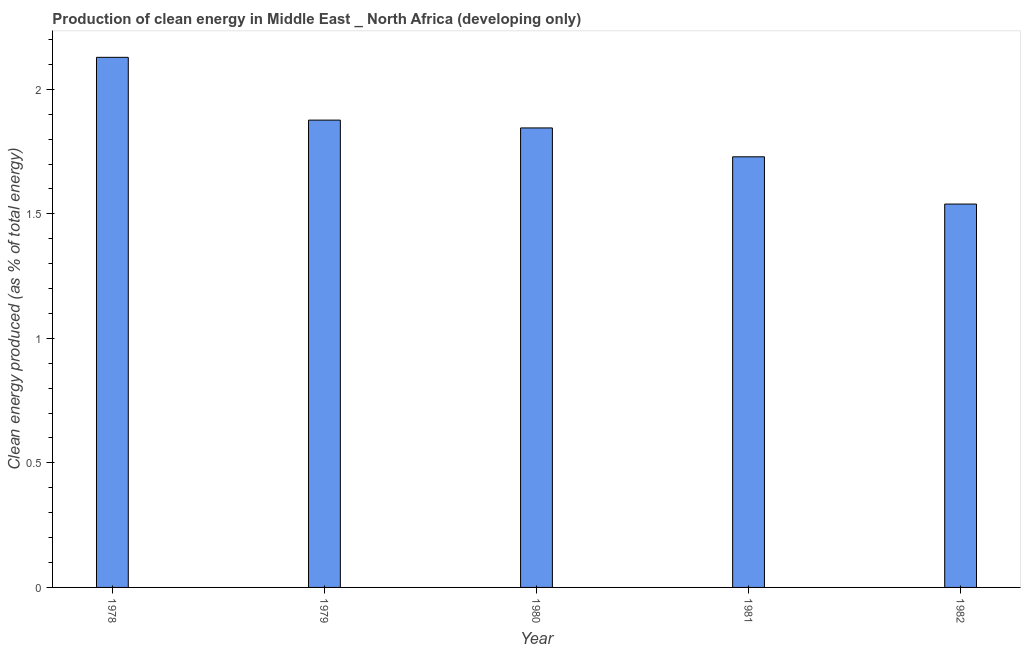Does the graph contain grids?
Ensure brevity in your answer.  No. What is the title of the graph?
Your answer should be very brief. Production of clean energy in Middle East _ North Africa (developing only). What is the label or title of the Y-axis?
Give a very brief answer. Clean energy produced (as % of total energy). What is the production of clean energy in 1978?
Keep it short and to the point. 2.13. Across all years, what is the maximum production of clean energy?
Offer a very short reply. 2.13. Across all years, what is the minimum production of clean energy?
Offer a very short reply. 1.54. In which year was the production of clean energy maximum?
Your response must be concise. 1978. In which year was the production of clean energy minimum?
Your response must be concise. 1982. What is the sum of the production of clean energy?
Provide a short and direct response. 9.12. What is the difference between the production of clean energy in 1978 and 1982?
Your answer should be very brief. 0.59. What is the average production of clean energy per year?
Provide a succinct answer. 1.82. What is the median production of clean energy?
Keep it short and to the point. 1.84. What is the ratio of the production of clean energy in 1978 to that in 1980?
Give a very brief answer. 1.15. Is the production of clean energy in 1979 less than that in 1980?
Make the answer very short. No. What is the difference between the highest and the second highest production of clean energy?
Make the answer very short. 0.25. Is the sum of the production of clean energy in 1981 and 1982 greater than the maximum production of clean energy across all years?
Your response must be concise. Yes. What is the difference between the highest and the lowest production of clean energy?
Make the answer very short. 0.59. In how many years, is the production of clean energy greater than the average production of clean energy taken over all years?
Give a very brief answer. 3. How many bars are there?
Your answer should be compact. 5. What is the difference between two consecutive major ticks on the Y-axis?
Offer a terse response. 0.5. Are the values on the major ticks of Y-axis written in scientific E-notation?
Your response must be concise. No. What is the Clean energy produced (as % of total energy) in 1978?
Your answer should be very brief. 2.13. What is the Clean energy produced (as % of total energy) in 1979?
Your answer should be very brief. 1.88. What is the Clean energy produced (as % of total energy) in 1980?
Keep it short and to the point. 1.84. What is the Clean energy produced (as % of total energy) of 1981?
Provide a short and direct response. 1.73. What is the Clean energy produced (as % of total energy) in 1982?
Provide a succinct answer. 1.54. What is the difference between the Clean energy produced (as % of total energy) in 1978 and 1979?
Your answer should be very brief. 0.25. What is the difference between the Clean energy produced (as % of total energy) in 1978 and 1980?
Offer a terse response. 0.28. What is the difference between the Clean energy produced (as % of total energy) in 1978 and 1981?
Make the answer very short. 0.4. What is the difference between the Clean energy produced (as % of total energy) in 1978 and 1982?
Offer a terse response. 0.59. What is the difference between the Clean energy produced (as % of total energy) in 1979 and 1980?
Offer a terse response. 0.03. What is the difference between the Clean energy produced (as % of total energy) in 1979 and 1981?
Your response must be concise. 0.15. What is the difference between the Clean energy produced (as % of total energy) in 1979 and 1982?
Make the answer very short. 0.34. What is the difference between the Clean energy produced (as % of total energy) in 1980 and 1981?
Make the answer very short. 0.12. What is the difference between the Clean energy produced (as % of total energy) in 1980 and 1982?
Offer a terse response. 0.31. What is the difference between the Clean energy produced (as % of total energy) in 1981 and 1982?
Make the answer very short. 0.19. What is the ratio of the Clean energy produced (as % of total energy) in 1978 to that in 1979?
Your answer should be compact. 1.13. What is the ratio of the Clean energy produced (as % of total energy) in 1978 to that in 1980?
Your response must be concise. 1.15. What is the ratio of the Clean energy produced (as % of total energy) in 1978 to that in 1981?
Offer a very short reply. 1.23. What is the ratio of the Clean energy produced (as % of total energy) in 1978 to that in 1982?
Your answer should be compact. 1.38. What is the ratio of the Clean energy produced (as % of total energy) in 1979 to that in 1980?
Offer a very short reply. 1.02. What is the ratio of the Clean energy produced (as % of total energy) in 1979 to that in 1981?
Keep it short and to the point. 1.08. What is the ratio of the Clean energy produced (as % of total energy) in 1979 to that in 1982?
Provide a short and direct response. 1.22. What is the ratio of the Clean energy produced (as % of total energy) in 1980 to that in 1981?
Your answer should be very brief. 1.07. What is the ratio of the Clean energy produced (as % of total energy) in 1980 to that in 1982?
Your answer should be compact. 1.2. What is the ratio of the Clean energy produced (as % of total energy) in 1981 to that in 1982?
Keep it short and to the point. 1.12. 